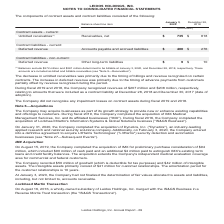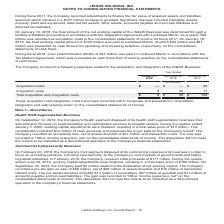According to Leidos Holdings's financial document, What was the increase in goodwill in 2017? According to the financial document, $337 million. The relevant text states: "assets and liabilities assumed which resulted in a $337 million increase in goodwill. Significant changes included intangible assets, property, plant and equipment,..." Also, What was the acquisition costs in the consolidated statements of income for fiscal 2017? According to the financial document, $24 million. The relevant text states: "ation Agreement with Lockheed Martin. As a result, $24 million was recorded as acquisition costs in the consolidated statements of income for fiscal 2017. On Janua ation Agreement with Lockheed Martin..." Also, What was the Integration costs in 2020, 2018 and 2017 respectively? The document contains multiple relevant values: 3, 29, 77 (in millions). From the document: "January 3, 2020 December 28, 2018 December 29, 2017 isition costs $ — $ — $ 25 Integration costs 3 29 77 Total acquisition and integration costs $ 3 $..." Additionally, In which year was Integration costs more than 20 million? The document shows two values: 2018 and 2017. Locate and analyze integration costs in row 6. From the document: "January 3, 2020 December 28, 2018 December 29, 2017 January 3, 2020 December 28, 2018 December 29, 2017..." Also, can you calculate: What was the change in the Total acquisition and integration costs from 2017 to 2018? Based on the calculation: 29 - 102, the result is -73 (in millions). This is based on the information: "January 3, 2020 December 28, 2018 December 29, 2017 otal acquisition and integration costs $ 3 $ 29 $ 102..." The key data points involved are: 102, 29. Also, can you calculate: What was the average Acquisition costs for 2017, 2018 and 2020? To answer this question, I need to perform calculations using the financial data. The calculation is: (0 + 0 + 25) / 3, which equals 8.33 (in millions). This is based on the information: "(in millions) Acquisition costs $ — $ — $ 25 Integration costs 3 29 77 Total acquisition and integration costs $ 3 $ 29 $ 102 January 3, 2020 December 28, 2018 December 29, 2017..." The key data points involved are: 0, 25. 